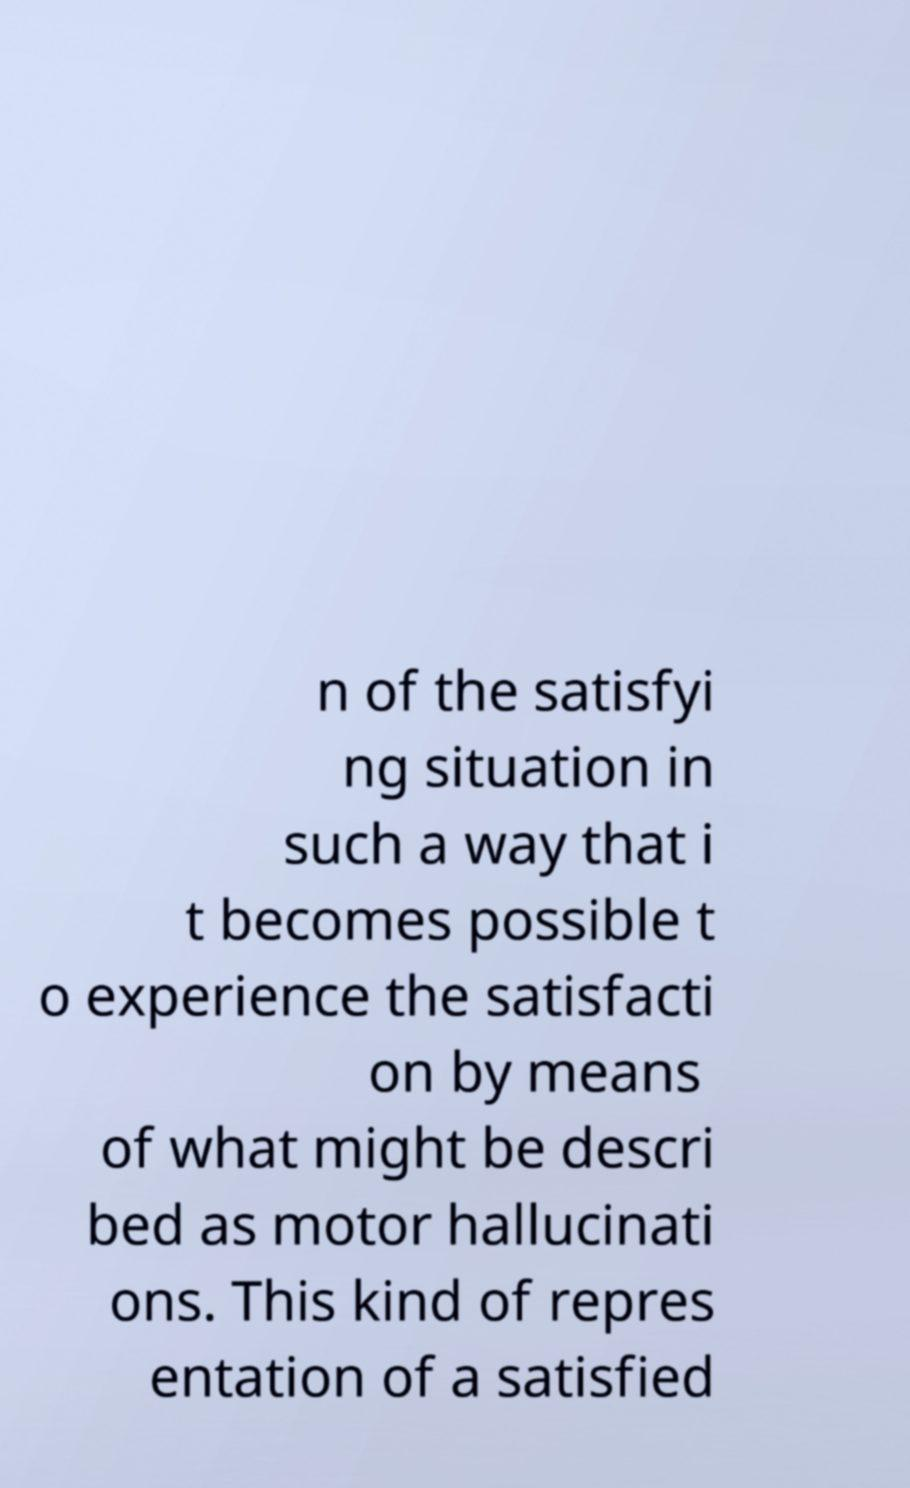Can you accurately transcribe the text from the provided image for me? n of the satisfyi ng situation in such a way that i t becomes possible t o experience the satisfacti on by means of what might be descri bed as motor hallucinati ons. This kind of repres entation of a satisfied 